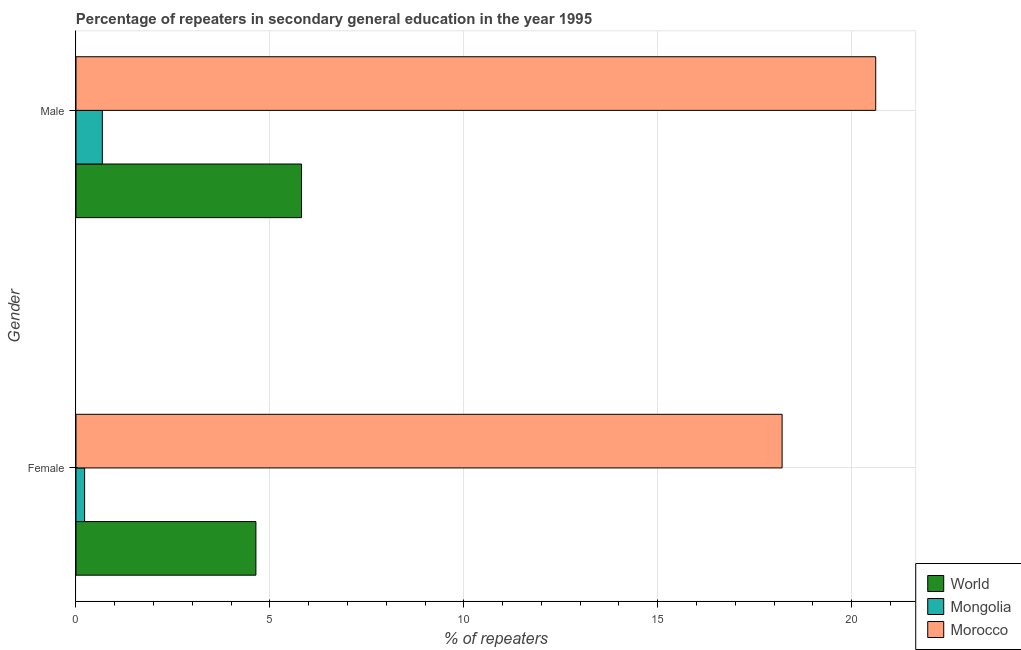Are the number of bars per tick equal to the number of legend labels?
Your answer should be compact. Yes. What is the label of the 2nd group of bars from the top?
Give a very brief answer. Female. What is the percentage of male repeaters in World?
Your response must be concise. 5.82. Across all countries, what is the maximum percentage of female repeaters?
Offer a terse response. 18.21. Across all countries, what is the minimum percentage of male repeaters?
Make the answer very short. 0.68. In which country was the percentage of male repeaters maximum?
Keep it short and to the point. Morocco. In which country was the percentage of male repeaters minimum?
Offer a terse response. Mongolia. What is the total percentage of female repeaters in the graph?
Provide a succinct answer. 23.07. What is the difference between the percentage of male repeaters in Morocco and that in World?
Make the answer very short. 14.8. What is the difference between the percentage of female repeaters in Morocco and the percentage of male repeaters in Mongolia?
Offer a very short reply. 17.53. What is the average percentage of male repeaters per country?
Ensure brevity in your answer.  9.04. What is the difference between the percentage of female repeaters and percentage of male repeaters in Morocco?
Offer a terse response. -2.41. In how many countries, is the percentage of male repeaters greater than 12 %?
Make the answer very short. 1. What is the ratio of the percentage of female repeaters in World to that in Mongolia?
Ensure brevity in your answer.  20.89. What does the 2nd bar from the top in Female represents?
Your answer should be compact. Mongolia. What does the 1st bar from the bottom in Male represents?
Provide a short and direct response. World. How many bars are there?
Offer a very short reply. 6. Are all the bars in the graph horizontal?
Give a very brief answer. Yes. Are the values on the major ticks of X-axis written in scientific E-notation?
Keep it short and to the point. No. Does the graph contain any zero values?
Your response must be concise. No. Does the graph contain grids?
Offer a very short reply. Yes. What is the title of the graph?
Offer a terse response. Percentage of repeaters in secondary general education in the year 1995. Does "Caribbean small states" appear as one of the legend labels in the graph?
Your answer should be compact. No. What is the label or title of the X-axis?
Make the answer very short. % of repeaters. What is the label or title of the Y-axis?
Ensure brevity in your answer.  Gender. What is the % of repeaters of World in Female?
Offer a terse response. 4.64. What is the % of repeaters of Mongolia in Female?
Give a very brief answer. 0.22. What is the % of repeaters of Morocco in Female?
Keep it short and to the point. 18.21. What is the % of repeaters of World in Male?
Offer a very short reply. 5.82. What is the % of repeaters in Mongolia in Male?
Keep it short and to the point. 0.68. What is the % of repeaters of Morocco in Male?
Provide a short and direct response. 20.62. Across all Gender, what is the maximum % of repeaters of World?
Give a very brief answer. 5.82. Across all Gender, what is the maximum % of repeaters in Mongolia?
Make the answer very short. 0.68. Across all Gender, what is the maximum % of repeaters of Morocco?
Give a very brief answer. 20.62. Across all Gender, what is the minimum % of repeaters in World?
Keep it short and to the point. 4.64. Across all Gender, what is the minimum % of repeaters in Mongolia?
Offer a terse response. 0.22. Across all Gender, what is the minimum % of repeaters in Morocco?
Your response must be concise. 18.21. What is the total % of repeaters in World in the graph?
Provide a short and direct response. 10.45. What is the total % of repeaters of Mongolia in the graph?
Your answer should be compact. 0.9. What is the total % of repeaters in Morocco in the graph?
Ensure brevity in your answer.  38.83. What is the difference between the % of repeaters of World in Female and that in Male?
Your response must be concise. -1.18. What is the difference between the % of repeaters in Mongolia in Female and that in Male?
Give a very brief answer. -0.46. What is the difference between the % of repeaters in Morocco in Female and that in Male?
Your response must be concise. -2.41. What is the difference between the % of repeaters of World in Female and the % of repeaters of Mongolia in Male?
Make the answer very short. 3.96. What is the difference between the % of repeaters in World in Female and the % of repeaters in Morocco in Male?
Your response must be concise. -15.98. What is the difference between the % of repeaters of Mongolia in Female and the % of repeaters of Morocco in Male?
Offer a very short reply. -20.4. What is the average % of repeaters of World per Gender?
Keep it short and to the point. 5.23. What is the average % of repeaters of Mongolia per Gender?
Offer a very short reply. 0.45. What is the average % of repeaters of Morocco per Gender?
Give a very brief answer. 19.41. What is the difference between the % of repeaters in World and % of repeaters in Mongolia in Female?
Make the answer very short. 4.42. What is the difference between the % of repeaters in World and % of repeaters in Morocco in Female?
Give a very brief answer. -13.57. What is the difference between the % of repeaters of Mongolia and % of repeaters of Morocco in Female?
Offer a terse response. -17.98. What is the difference between the % of repeaters in World and % of repeaters in Mongolia in Male?
Keep it short and to the point. 5.14. What is the difference between the % of repeaters in World and % of repeaters in Morocco in Male?
Give a very brief answer. -14.8. What is the difference between the % of repeaters of Mongolia and % of repeaters of Morocco in Male?
Offer a terse response. -19.94. What is the ratio of the % of repeaters in World in Female to that in Male?
Your answer should be very brief. 0.8. What is the ratio of the % of repeaters of Mongolia in Female to that in Male?
Make the answer very short. 0.33. What is the ratio of the % of repeaters in Morocco in Female to that in Male?
Provide a succinct answer. 0.88. What is the difference between the highest and the second highest % of repeaters in World?
Offer a very short reply. 1.18. What is the difference between the highest and the second highest % of repeaters of Mongolia?
Give a very brief answer. 0.46. What is the difference between the highest and the second highest % of repeaters in Morocco?
Your response must be concise. 2.41. What is the difference between the highest and the lowest % of repeaters of World?
Provide a succinct answer. 1.18. What is the difference between the highest and the lowest % of repeaters in Mongolia?
Keep it short and to the point. 0.46. What is the difference between the highest and the lowest % of repeaters of Morocco?
Provide a short and direct response. 2.41. 